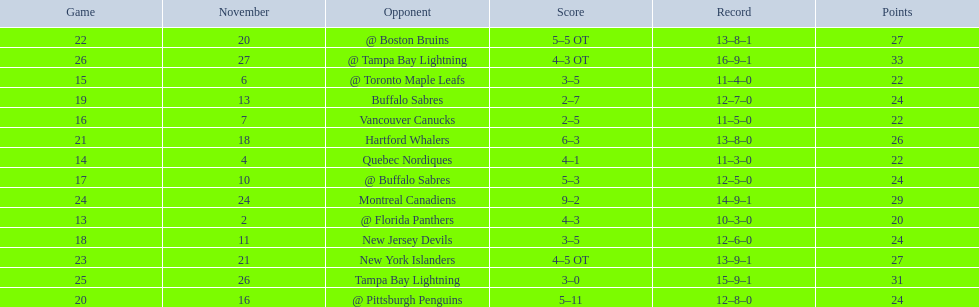Who did the philadelphia flyers play in game 17? @ Buffalo Sabres. What was the score of the november 10th game against the buffalo sabres? 5–3. Which team in the atlantic division had less points than the philadelphia flyers? Tampa Bay Lightning. 